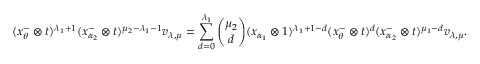<formula> <loc_0><loc_0><loc_500><loc_500>( x _ { \theta } ^ { - } \otimes t ) ^ { \lambda _ { 1 } + 1 } ( x _ { \alpha _ { 2 } } ^ { - } \otimes t ) ^ { \mu _ { 2 } - \lambda _ { 1 } - 1 } v _ { \lambda , \mu } = \sum _ { d = 0 } ^ { \lambda _ { 1 } } { \binom { \mu _ { 2 } } { d } } ( x _ { \alpha _ { 1 } } \otimes 1 ) ^ { \lambda _ { 1 } + 1 - d } ( x _ { \theta } ^ { - } \otimes t ) ^ { d } ( x _ { \alpha _ { 2 } } ^ { - } \otimes t ) ^ { \mu _ { 1 } - d } v _ { \lambda , \mu } .</formula> 